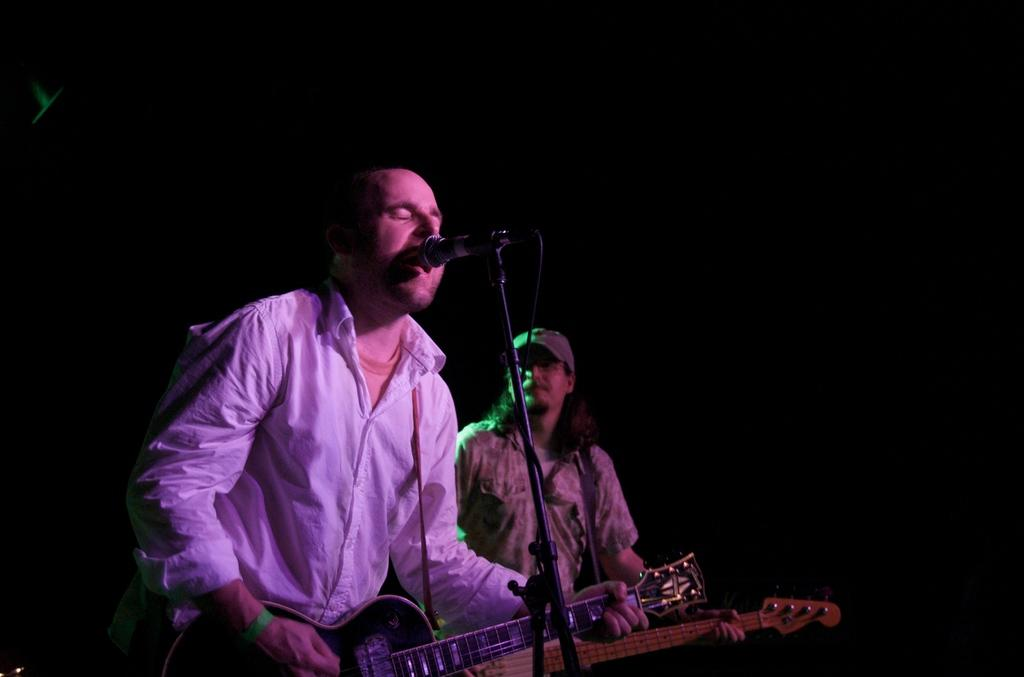What is the man in the image doing? The man is singing on a mic and playing a guitar. Is there anyone else in the image? Yes, there is another person in the image. What is the other person doing? The other person is also playing a guitar. What type of flesh can be seen on the guitar in the image? There is no flesh visible in the image, as guitars are made of materials like wood and metal, not flesh. 